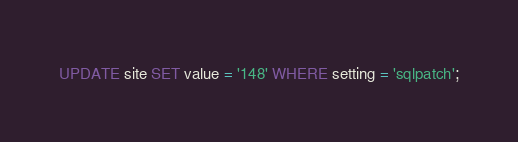<code> <loc_0><loc_0><loc_500><loc_500><_SQL_>UPDATE site SET value = '148' WHERE setting = 'sqlpatch';
</code> 